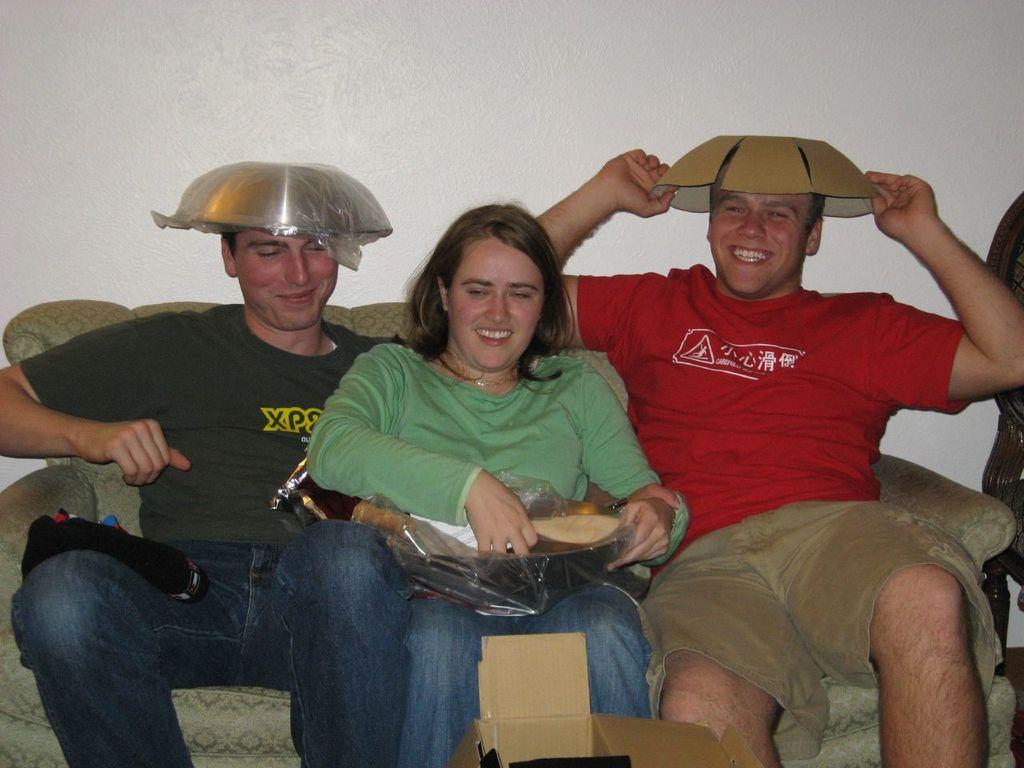Can you describe this image briefly? In this image, we can see three persons wearing clothes and sitting on the sofa in front of the wall. There is a person on the left and on the right side of the image wearing bowls on their heads. 